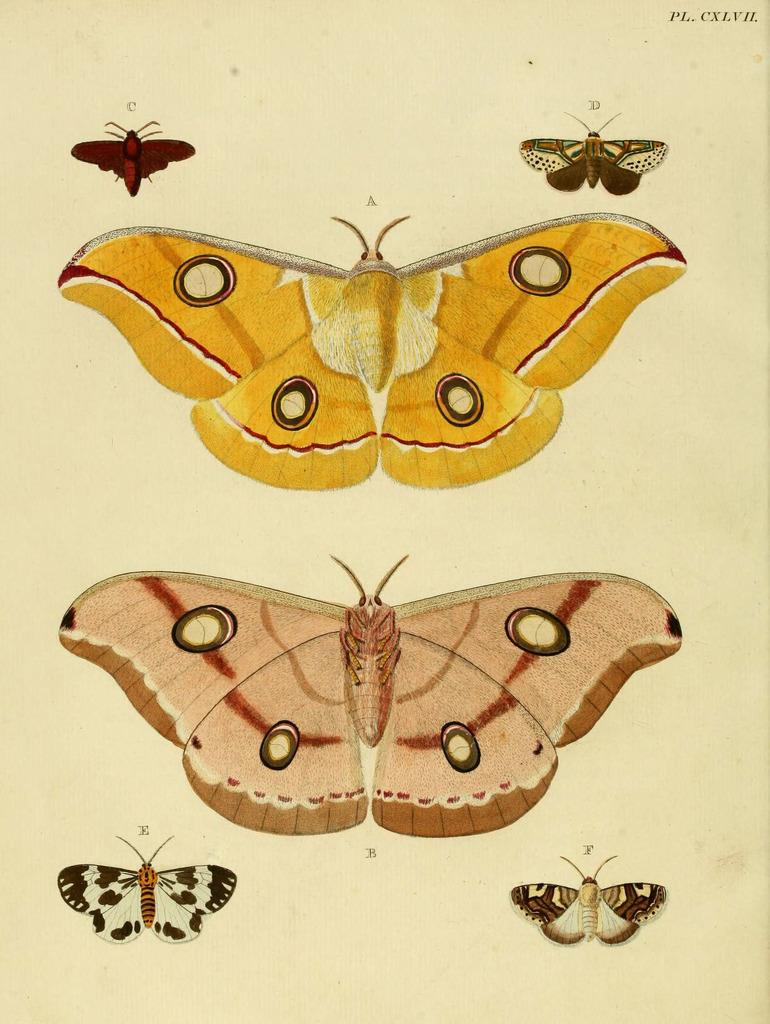What is depicted on the paper in the image? There are butterfly images on the paper. Can you describe the butterfly images in more detail? The butterfly images have different designs. What is the opinion of the butterflies on the sign in the image? There is no sign present in the image, and therefore no opinion can be attributed to the butterflies. 